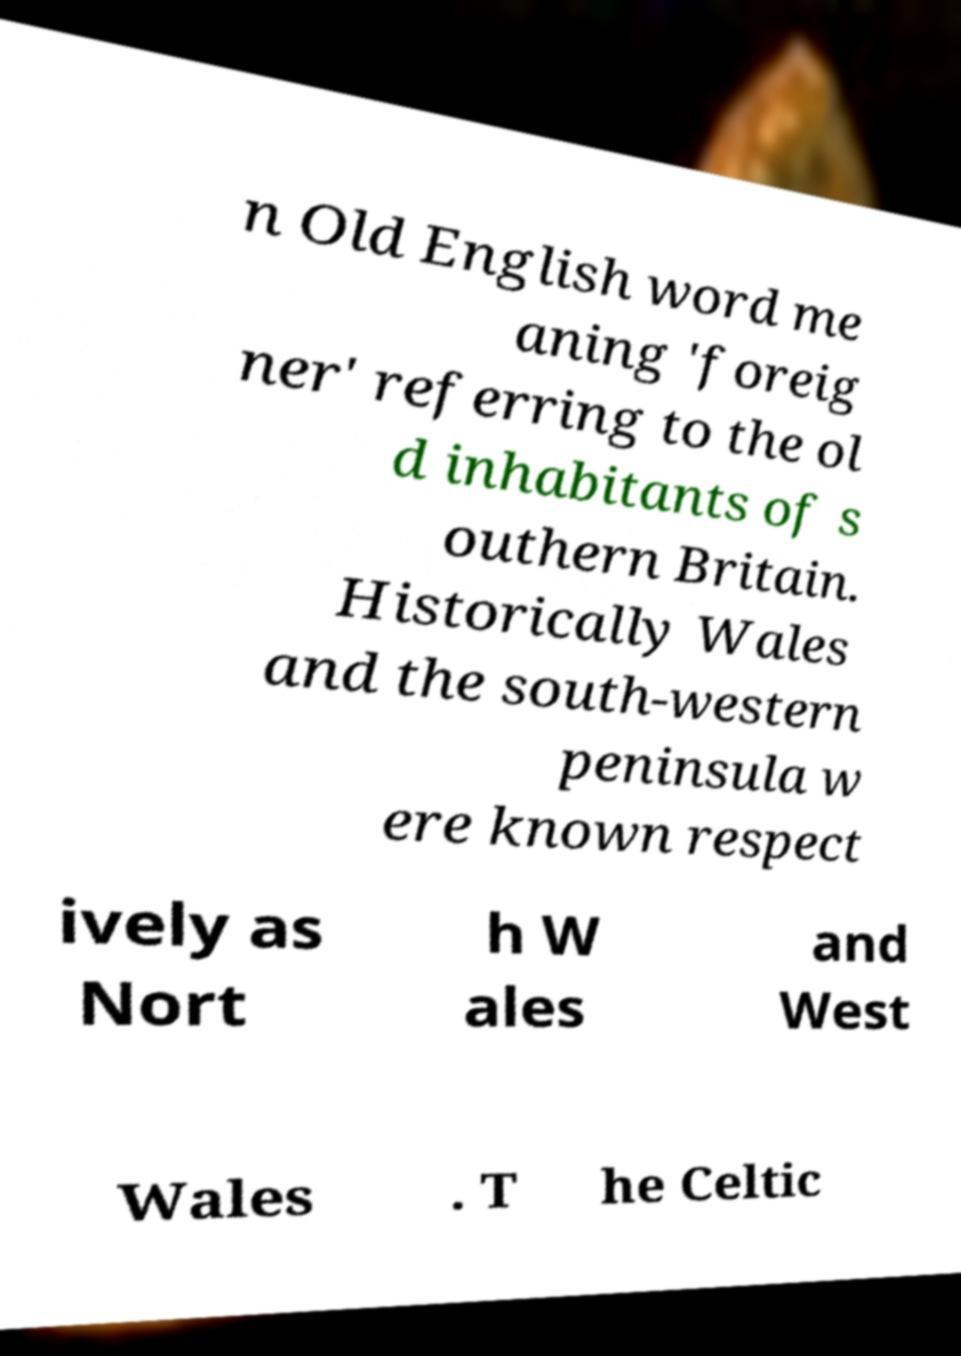What messages or text are displayed in this image? I need them in a readable, typed format. n Old English word me aning 'foreig ner' referring to the ol d inhabitants of s outhern Britain. Historically Wales and the south-western peninsula w ere known respect ively as Nort h W ales and West Wales . T he Celtic 